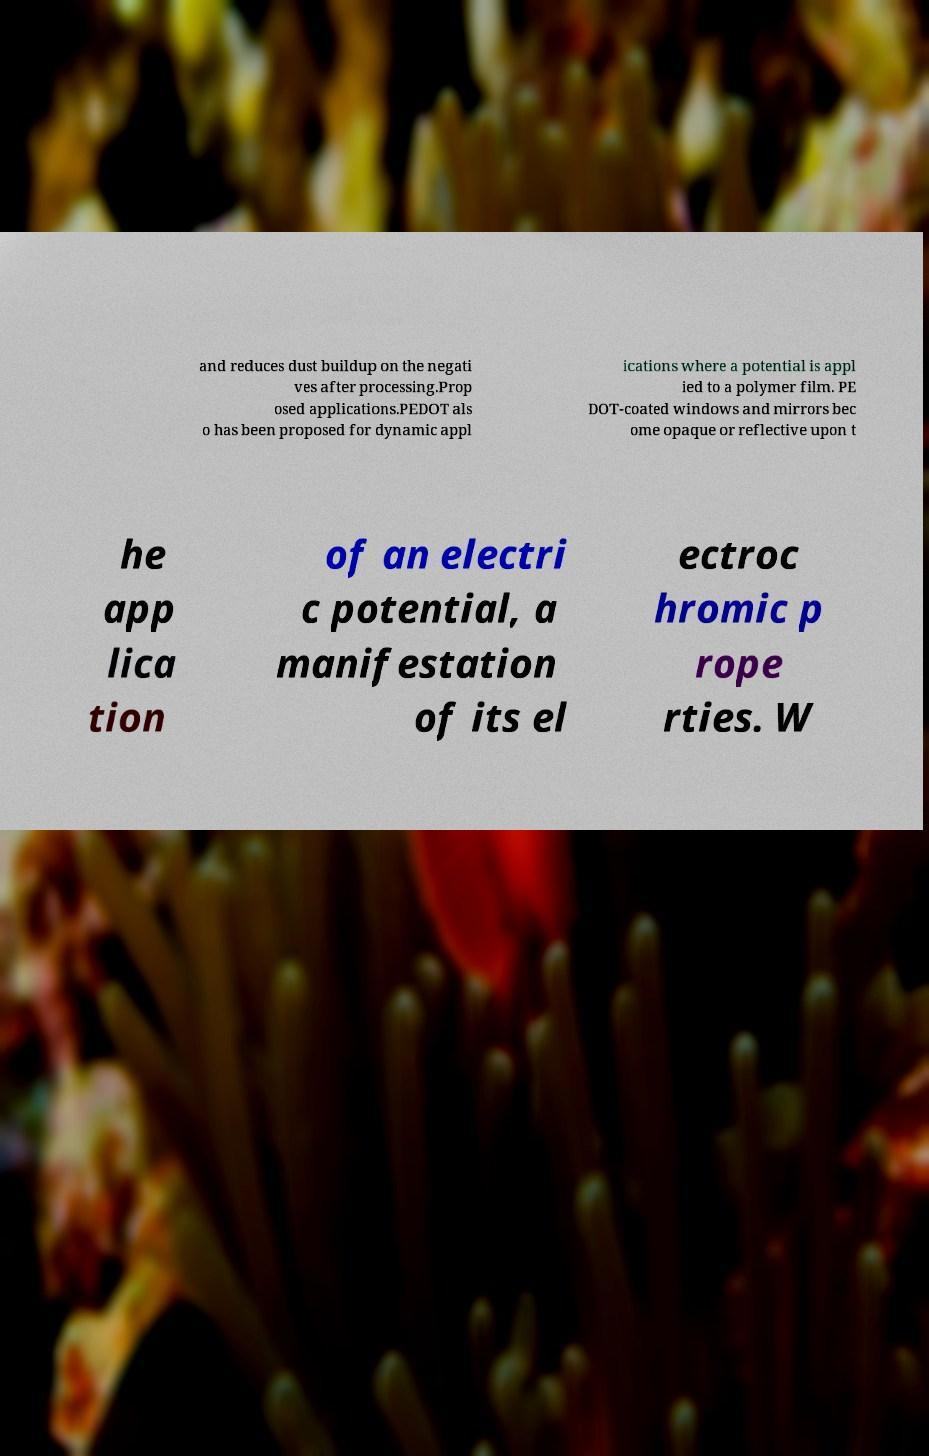Please read and relay the text visible in this image. What does it say? and reduces dust buildup on the negati ves after processing.Prop osed applications.PEDOT als o has been proposed for dynamic appl ications where a potential is appl ied to a polymer film. PE DOT-coated windows and mirrors bec ome opaque or reflective upon t he app lica tion of an electri c potential, a manifestation of its el ectroc hromic p rope rties. W 